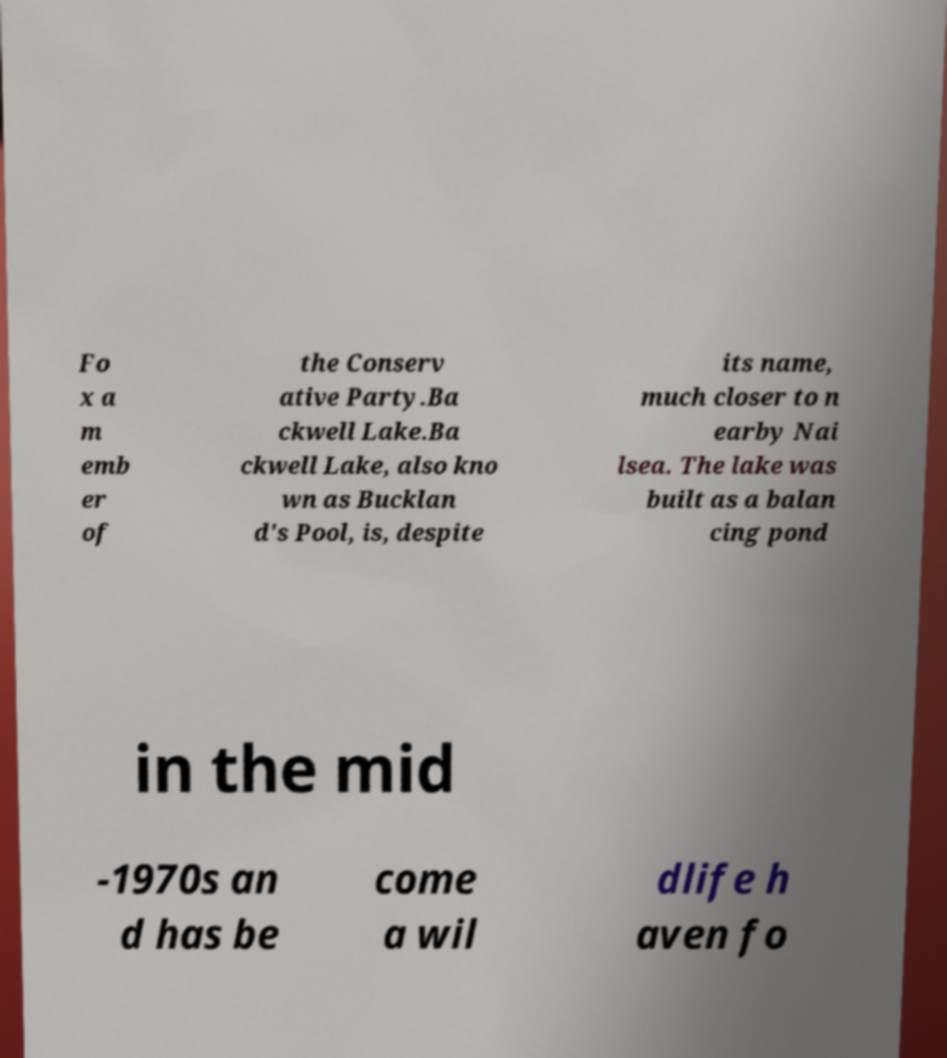There's text embedded in this image that I need extracted. Can you transcribe it verbatim? Fo x a m emb er of the Conserv ative Party.Ba ckwell Lake.Ba ckwell Lake, also kno wn as Bucklan d's Pool, is, despite its name, much closer to n earby Nai lsea. The lake was built as a balan cing pond in the mid -1970s an d has be come a wil dlife h aven fo 